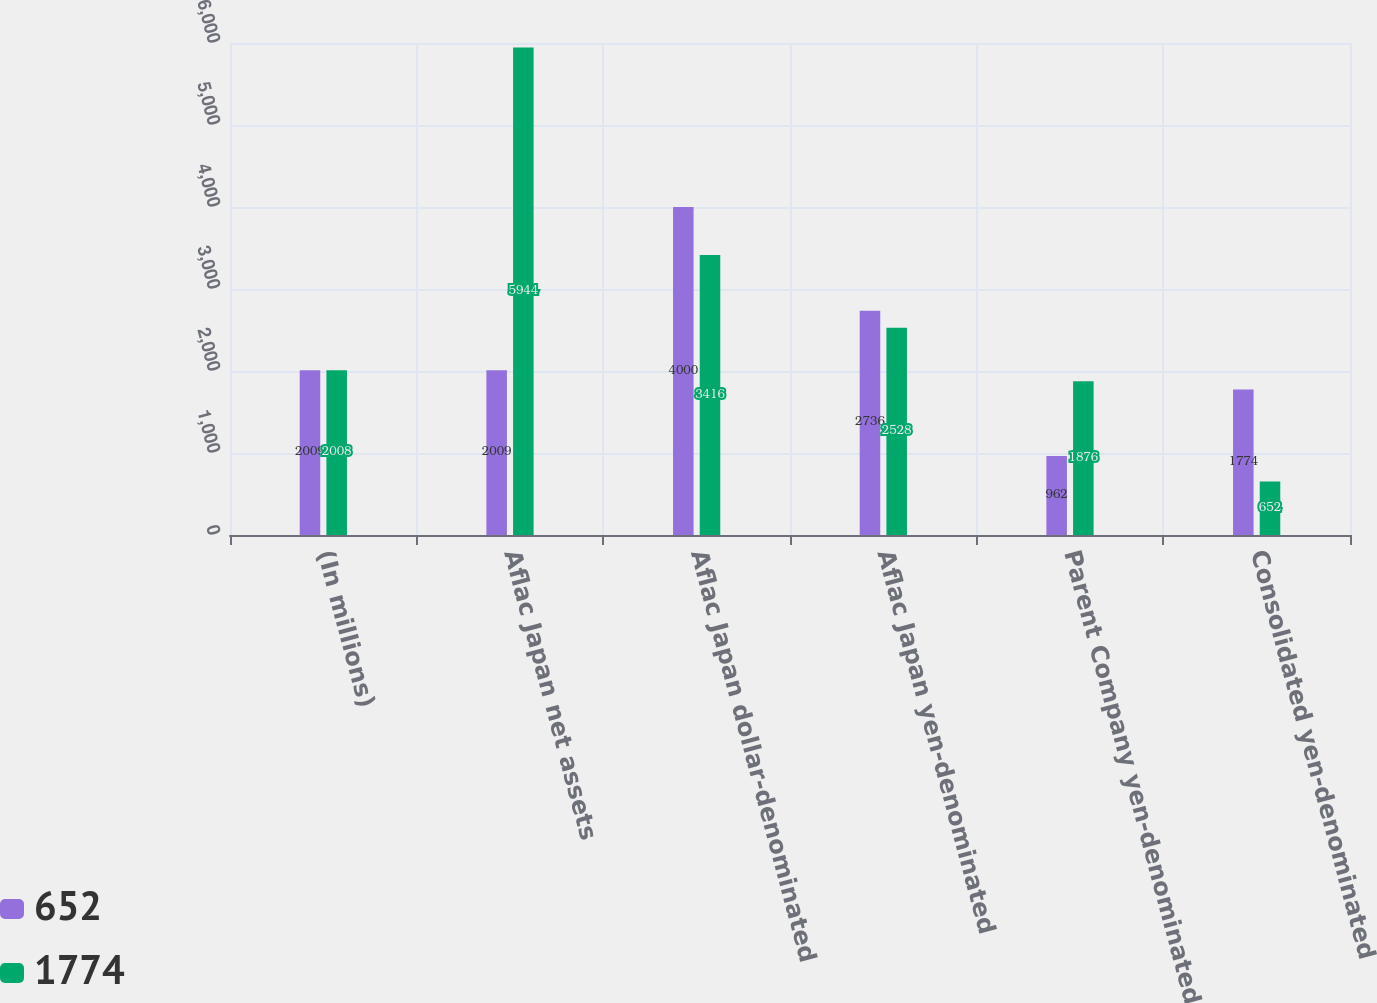Convert chart to OTSL. <chart><loc_0><loc_0><loc_500><loc_500><stacked_bar_chart><ecel><fcel>(In millions)<fcel>Aflac Japan net assets<fcel>Aflac Japan dollar-denominated<fcel>Aflac Japan yen-denominated<fcel>Parent Company yen-denominated<fcel>Consolidated yen-denominated<nl><fcel>652<fcel>2009<fcel>2009<fcel>4000<fcel>2736<fcel>962<fcel>1774<nl><fcel>1774<fcel>2008<fcel>5944<fcel>3416<fcel>2528<fcel>1876<fcel>652<nl></chart> 